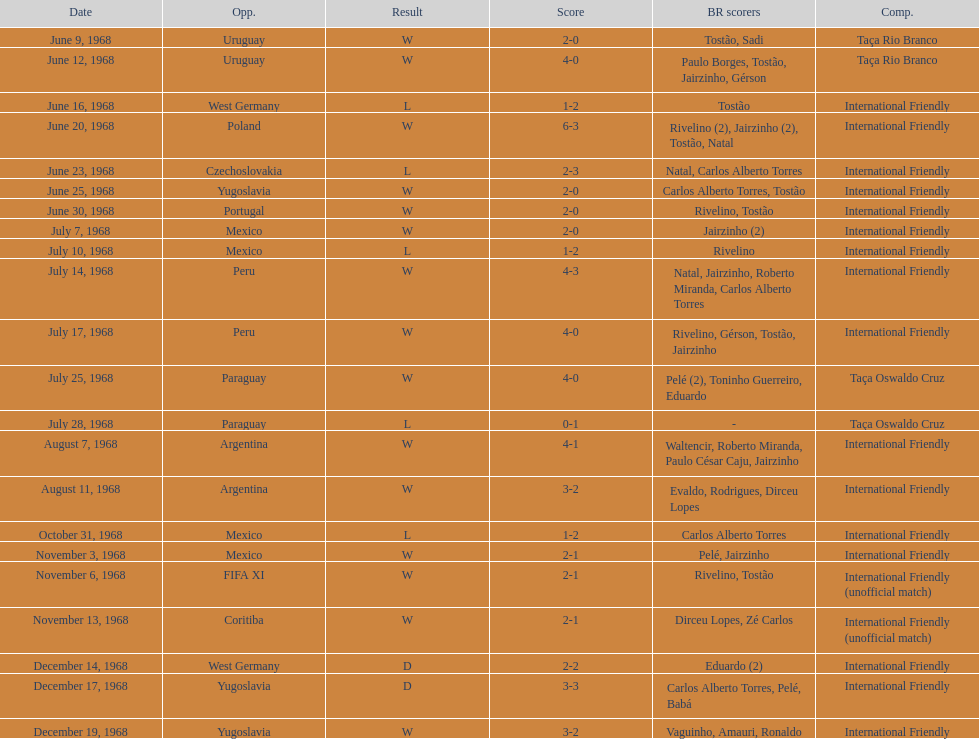What is the top score ever scored by the brazil national team? 6. 